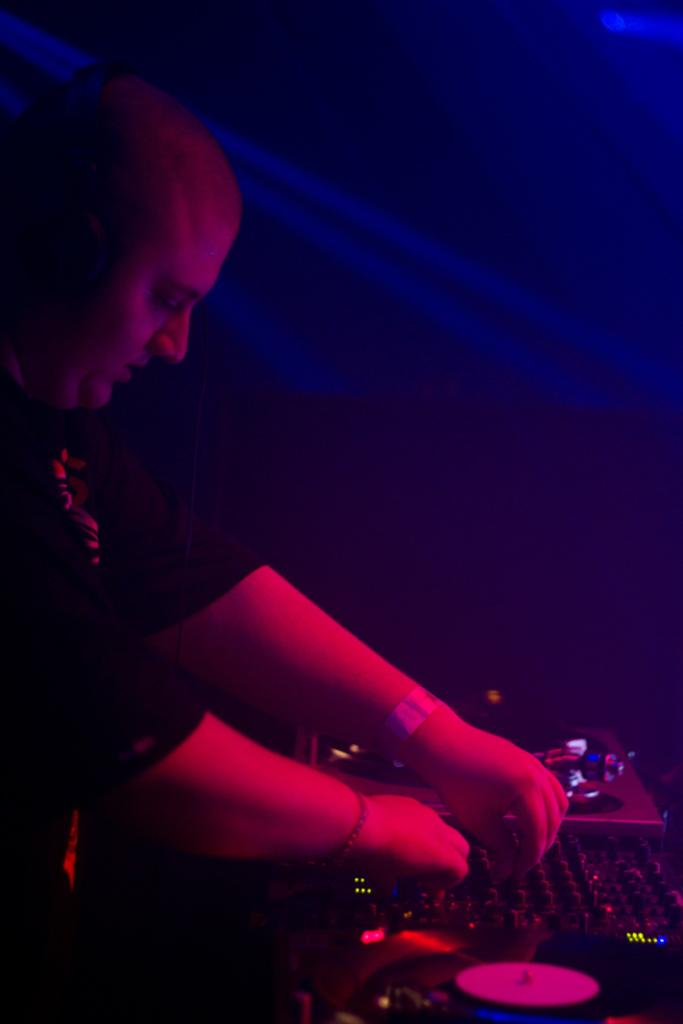What is the main subject of the image? The main subject of the image is a man. What is the man doing in the image? The man is playing the role of a DJ in the image. What type of joke is the man telling in the image? There is no joke being told in the image; the man is playing the role of a DJ. Is the man operating a plantation in the image? No, the man is not operating a plantation in the image; he is playing the role of a DJ. 